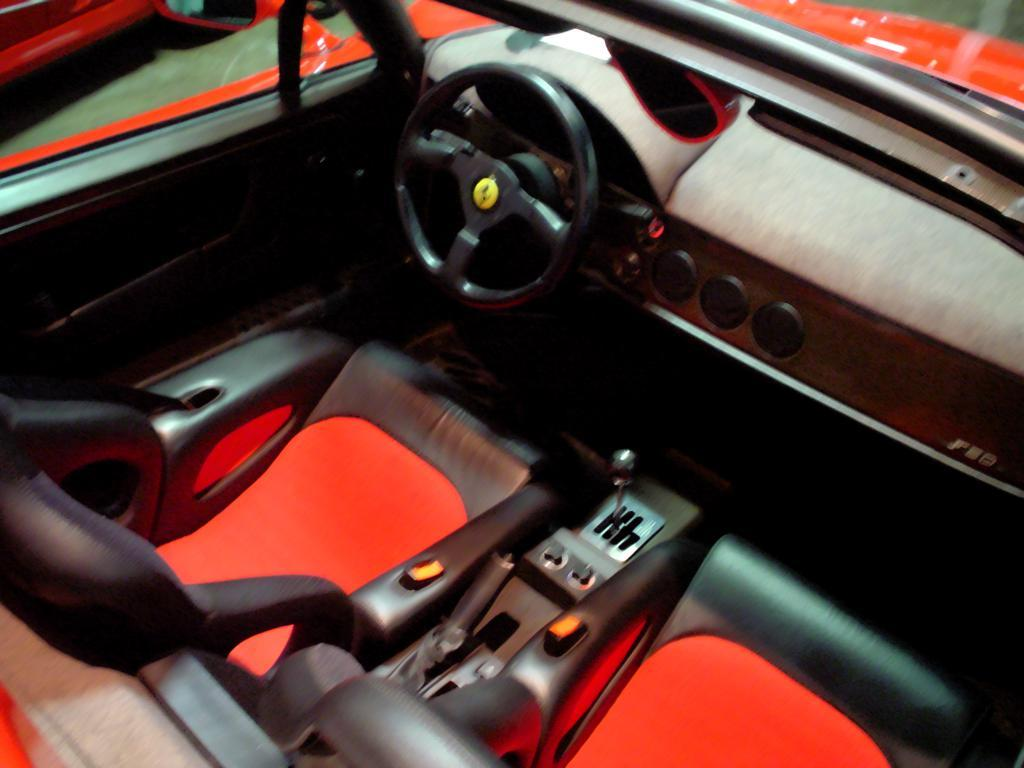What is the setting of the image? The image depicts the interior of a car. What can be found inside the car? There are seats in the car. What colors are the seats? The seats have a combination of red and black colors. Can you see a goldfish swimming in the car's interior in the image? No, there is no goldfish present in the image. 